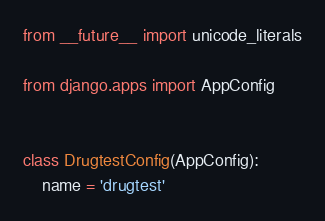<code> <loc_0><loc_0><loc_500><loc_500><_Python_>from __future__ import unicode_literals

from django.apps import AppConfig


class DrugtestConfig(AppConfig):
    name = 'drugtest'
</code> 